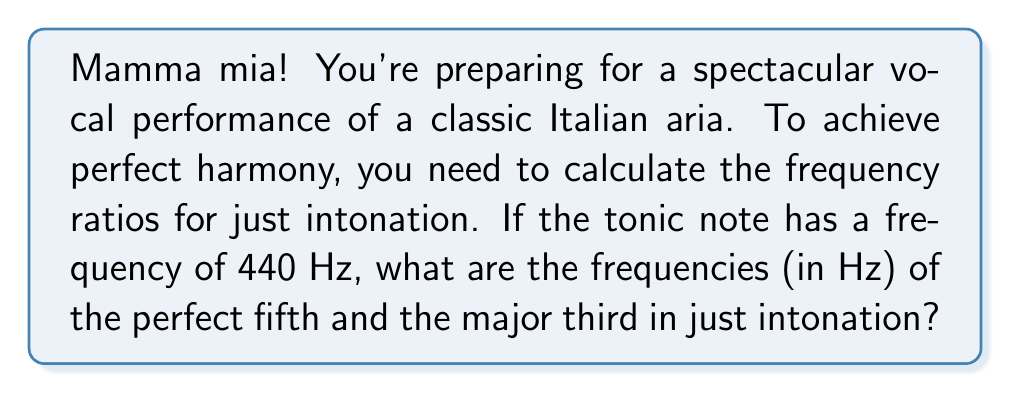Could you help me with this problem? Let's break this down step-by-step, bella:

1) In just intonation, the frequency ratios are based on small whole number ratios.

2) The perfect fifth has a ratio of 3:2 relative to the tonic.
   The major third has a ratio of 5:4 relative to the tonic.

3) Given the tonic frequency of 440 Hz:

   For the perfect fifth:
   $$ f_{fifth} = 440 \cdot \frac{3}{2} = 660 \text{ Hz} $$

   For the major third:
   $$ f_{third} = 440 \cdot \frac{5}{4} = 550 \text{ Hz} $$

4) To verify, we can check the ratio between the fifth and the third:
   $$ \frac{f_{fifth}}{f_{third}} = \frac{660}{550} = \frac{6}{5} $$
   This is indeed the correct ratio for a just major third (5:4) relative to the fifth (3:2).

5) These frequency ratios ensure a pure, harmonious sound that will make your performance truly bellissimo!
Answer: The frequency of the perfect fifth is 660 Hz, and the frequency of the major third is 550 Hz. 